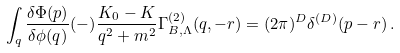<formula> <loc_0><loc_0><loc_500><loc_500>\int _ { q } \frac { \delta \Phi ( p ) } { \delta \phi ( q ) } ( - ) \frac { K _ { 0 } - K } { q ^ { 2 } + m ^ { 2 } } \Gamma _ { B , \Lambda } ^ { ( 2 ) } ( q , - r ) = ( 2 \pi ) ^ { D } \delta ^ { ( D ) } ( p - r ) \, .</formula> 